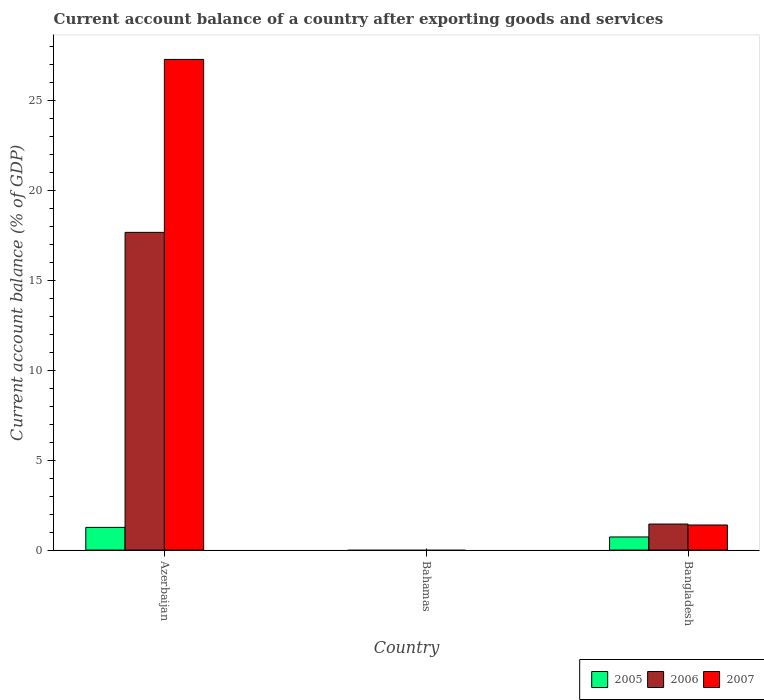Are the number of bars on each tick of the X-axis equal?
Provide a short and direct response. No. How many bars are there on the 1st tick from the left?
Make the answer very short. 3. How many bars are there on the 1st tick from the right?
Keep it short and to the point. 3. What is the label of the 3rd group of bars from the left?
Offer a terse response. Bangladesh. In how many cases, is the number of bars for a given country not equal to the number of legend labels?
Offer a very short reply. 1. What is the account balance in 2007 in Azerbaijan?
Provide a succinct answer. 27.29. Across all countries, what is the maximum account balance in 2007?
Provide a succinct answer. 27.29. Across all countries, what is the minimum account balance in 2007?
Offer a very short reply. 0. In which country was the account balance in 2005 maximum?
Your answer should be very brief. Azerbaijan. What is the total account balance in 2007 in the graph?
Give a very brief answer. 28.69. What is the difference between the account balance in 2006 in Azerbaijan and that in Bangladesh?
Keep it short and to the point. 16.22. What is the difference between the account balance in 2006 in Azerbaijan and the account balance in 2005 in Bangladesh?
Make the answer very short. 16.94. What is the average account balance in 2006 per country?
Make the answer very short. 6.37. What is the difference between the account balance of/in 2007 and account balance of/in 2005 in Bangladesh?
Make the answer very short. 0.67. What is the ratio of the account balance in 2006 in Azerbaijan to that in Bangladesh?
Ensure brevity in your answer.  12.19. Is the account balance in 2006 in Azerbaijan less than that in Bangladesh?
Provide a succinct answer. No. Is the difference between the account balance in 2007 in Azerbaijan and Bangladesh greater than the difference between the account balance in 2005 in Azerbaijan and Bangladesh?
Ensure brevity in your answer.  Yes. What is the difference between the highest and the lowest account balance in 2005?
Your response must be concise. 1.26. Is it the case that in every country, the sum of the account balance in 2005 and account balance in 2006 is greater than the account balance in 2007?
Provide a succinct answer. No. How many bars are there?
Ensure brevity in your answer.  6. What is the difference between two consecutive major ticks on the Y-axis?
Give a very brief answer. 5. Where does the legend appear in the graph?
Your answer should be compact. Bottom right. How many legend labels are there?
Your answer should be very brief. 3. How are the legend labels stacked?
Your answer should be compact. Horizontal. What is the title of the graph?
Keep it short and to the point. Current account balance of a country after exporting goods and services. Does "1970" appear as one of the legend labels in the graph?
Make the answer very short. No. What is the label or title of the X-axis?
Keep it short and to the point. Country. What is the label or title of the Y-axis?
Keep it short and to the point. Current account balance (% of GDP). What is the Current account balance (% of GDP) of 2005 in Azerbaijan?
Provide a succinct answer. 1.26. What is the Current account balance (% of GDP) in 2006 in Azerbaijan?
Make the answer very short. 17.67. What is the Current account balance (% of GDP) of 2007 in Azerbaijan?
Offer a terse response. 27.29. What is the Current account balance (% of GDP) in 2005 in Bahamas?
Keep it short and to the point. 0. What is the Current account balance (% of GDP) of 2006 in Bahamas?
Offer a terse response. 0. What is the Current account balance (% of GDP) in 2007 in Bahamas?
Your response must be concise. 0. What is the Current account balance (% of GDP) in 2005 in Bangladesh?
Make the answer very short. 0.73. What is the Current account balance (% of GDP) in 2006 in Bangladesh?
Offer a very short reply. 1.45. What is the Current account balance (% of GDP) in 2007 in Bangladesh?
Ensure brevity in your answer.  1.4. Across all countries, what is the maximum Current account balance (% of GDP) in 2005?
Ensure brevity in your answer.  1.26. Across all countries, what is the maximum Current account balance (% of GDP) of 2006?
Offer a very short reply. 17.67. Across all countries, what is the maximum Current account balance (% of GDP) of 2007?
Offer a very short reply. 27.29. Across all countries, what is the minimum Current account balance (% of GDP) in 2006?
Offer a terse response. 0. What is the total Current account balance (% of GDP) in 2005 in the graph?
Give a very brief answer. 1.99. What is the total Current account balance (% of GDP) of 2006 in the graph?
Offer a very short reply. 19.12. What is the total Current account balance (% of GDP) of 2007 in the graph?
Provide a short and direct response. 28.69. What is the difference between the Current account balance (% of GDP) in 2005 in Azerbaijan and that in Bangladesh?
Your answer should be very brief. 0.53. What is the difference between the Current account balance (% of GDP) of 2006 in Azerbaijan and that in Bangladesh?
Make the answer very short. 16.22. What is the difference between the Current account balance (% of GDP) in 2007 in Azerbaijan and that in Bangladesh?
Offer a terse response. 25.89. What is the difference between the Current account balance (% of GDP) of 2005 in Azerbaijan and the Current account balance (% of GDP) of 2006 in Bangladesh?
Make the answer very short. -0.19. What is the difference between the Current account balance (% of GDP) of 2005 in Azerbaijan and the Current account balance (% of GDP) of 2007 in Bangladesh?
Ensure brevity in your answer.  -0.13. What is the difference between the Current account balance (% of GDP) of 2006 in Azerbaijan and the Current account balance (% of GDP) of 2007 in Bangladesh?
Make the answer very short. 16.27. What is the average Current account balance (% of GDP) of 2005 per country?
Give a very brief answer. 0.66. What is the average Current account balance (% of GDP) of 2006 per country?
Provide a succinct answer. 6.37. What is the average Current account balance (% of GDP) of 2007 per country?
Provide a succinct answer. 9.56. What is the difference between the Current account balance (% of GDP) in 2005 and Current account balance (% of GDP) in 2006 in Azerbaijan?
Your answer should be very brief. -16.41. What is the difference between the Current account balance (% of GDP) of 2005 and Current account balance (% of GDP) of 2007 in Azerbaijan?
Your response must be concise. -26.03. What is the difference between the Current account balance (% of GDP) in 2006 and Current account balance (% of GDP) in 2007 in Azerbaijan?
Provide a succinct answer. -9.62. What is the difference between the Current account balance (% of GDP) in 2005 and Current account balance (% of GDP) in 2006 in Bangladesh?
Your answer should be compact. -0.72. What is the difference between the Current account balance (% of GDP) of 2005 and Current account balance (% of GDP) of 2007 in Bangladesh?
Give a very brief answer. -0.67. What is the difference between the Current account balance (% of GDP) of 2006 and Current account balance (% of GDP) of 2007 in Bangladesh?
Ensure brevity in your answer.  0.05. What is the ratio of the Current account balance (% of GDP) in 2005 in Azerbaijan to that in Bangladesh?
Make the answer very short. 1.73. What is the ratio of the Current account balance (% of GDP) of 2006 in Azerbaijan to that in Bangladesh?
Keep it short and to the point. 12.19. What is the ratio of the Current account balance (% of GDP) of 2007 in Azerbaijan to that in Bangladesh?
Your answer should be very brief. 19.54. What is the difference between the highest and the lowest Current account balance (% of GDP) of 2005?
Offer a terse response. 1.26. What is the difference between the highest and the lowest Current account balance (% of GDP) of 2006?
Make the answer very short. 17.67. What is the difference between the highest and the lowest Current account balance (% of GDP) in 2007?
Keep it short and to the point. 27.29. 